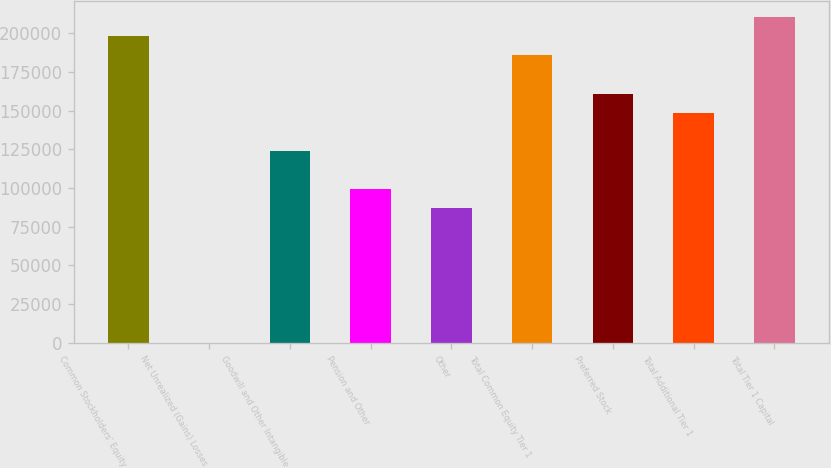<chart> <loc_0><loc_0><loc_500><loc_500><bar_chart><fcel>Common Stockholders' Equity<fcel>Net Unrealized (Gains) Losses<fcel>Goodwill and Other Intangible<fcel>Pension and Other<fcel>Other<fcel>Total Common Equity Tier 1<fcel>Preferred Stock<fcel>Total Additional Tier 1<fcel>Total Tier 1 Capital<nl><fcel>198282<fcel>2.4<fcel>123927<fcel>99142<fcel>86749.6<fcel>185889<fcel>161104<fcel>148712<fcel>210674<nl></chart> 